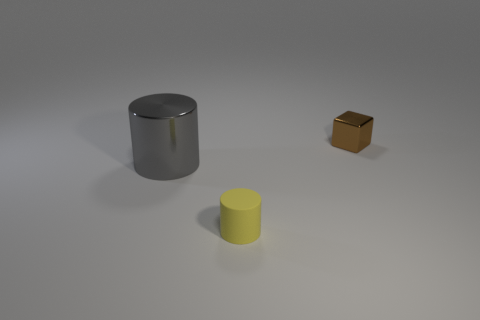Is there any other thing that has the same size as the gray metal cylinder?
Your answer should be compact. No. There is a yellow object that is the same size as the shiny cube; what shape is it?
Offer a very short reply. Cylinder. Are there fewer large purple cylinders than small brown shiny cubes?
Provide a short and direct response. Yes. Are there any large cylinders behind the cylinder on the right side of the gray metallic cylinder?
Ensure brevity in your answer.  Yes. What shape is the large gray thing that is the same material as the brown thing?
Your answer should be compact. Cylinder. Are there any other things of the same color as the tiny shiny thing?
Ensure brevity in your answer.  No. There is another object that is the same shape as the matte thing; what is it made of?
Provide a short and direct response. Metal. What number of other objects are there of the same size as the gray thing?
Make the answer very short. 0. There is a shiny thing that is left of the brown block; is it the same shape as the yellow thing?
Provide a succinct answer. Yes. How many other things are the same shape as the brown thing?
Ensure brevity in your answer.  0. 